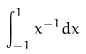<formula> <loc_0><loc_0><loc_500><loc_500>\int _ { - 1 } ^ { 1 } x ^ { - 1 } d x</formula> 